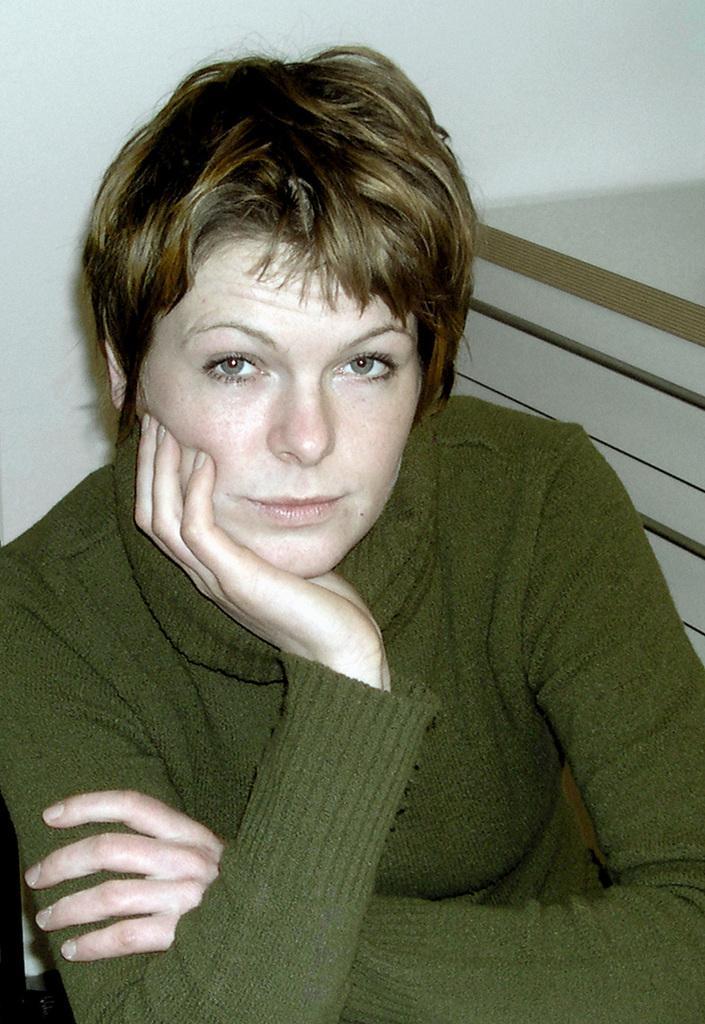Describe this image in one or two sentences. In this picture I can see a woman who is wearing dark green color dress. In the background I can see the white color wall and on the right side of this picture I can see brown color things. 